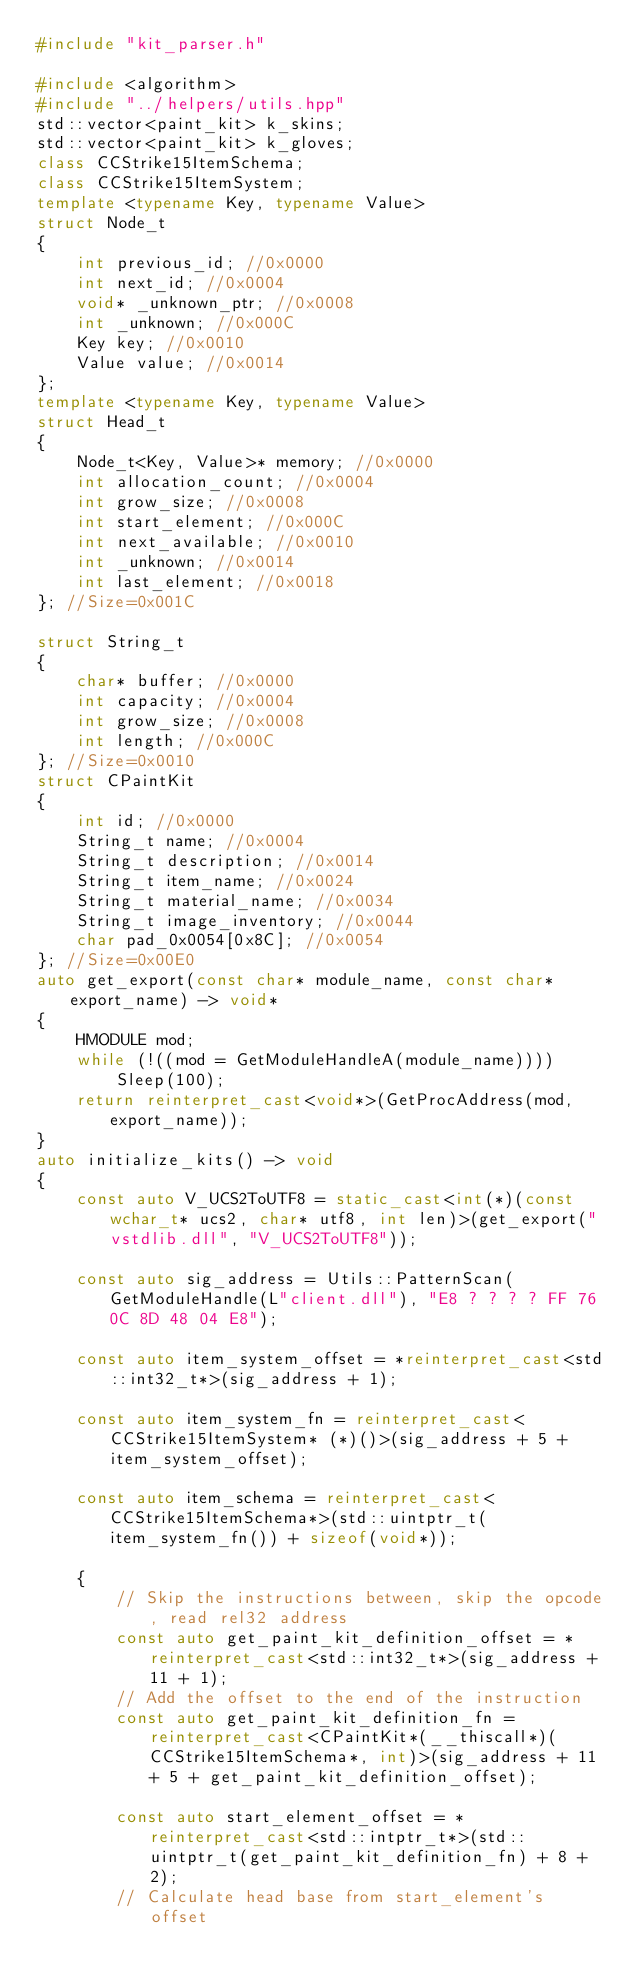Convert code to text. <code><loc_0><loc_0><loc_500><loc_500><_C++_>#include "kit_parser.h"

#include <algorithm>
#include "../helpers/utils.hpp"
std::vector<paint_kit> k_skins;
std::vector<paint_kit> k_gloves;
class CCStrike15ItemSchema;
class CCStrike15ItemSystem;
template <typename Key, typename Value>
struct Node_t
{
	int previous_id; //0x0000
	int next_id; //0x0004
	void* _unknown_ptr; //0x0008
	int _unknown; //0x000C
	Key key; //0x0010
	Value value; //0x0014
};
template <typename Key, typename Value>
struct Head_t
{
	Node_t<Key, Value>* memory; //0x0000
	int allocation_count; //0x0004
	int grow_size; //0x0008
	int start_element; //0x000C
	int next_available; //0x0010
	int _unknown; //0x0014
	int last_element; //0x0018
}; //Size=0x001C
  
struct String_t
{
	char* buffer; //0x0000
	int capacity; //0x0004
	int grow_size; //0x0008
	int length; //0x000C
}; //Size=0x0010
struct CPaintKit
{
	int id; //0x0000
	String_t name; //0x0004
	String_t description; //0x0014
	String_t item_name; //0x0024
	String_t material_name; //0x0034
	String_t image_inventory; //0x0044
	char pad_0x0054[0x8C]; //0x0054
}; //Size=0x00E0
auto get_export(const char* module_name, const char* export_name) -> void*
{
	HMODULE mod;
	while (!((mod = GetModuleHandleA(module_name))))
		Sleep(100);
	return reinterpret_cast<void*>(GetProcAddress(mod, export_name));
}
auto initialize_kits() -> void
{
	const auto V_UCS2ToUTF8 = static_cast<int(*)(const wchar_t* ucs2, char* utf8, int len)>(get_export("vstdlib.dll", "V_UCS2ToUTF8"));

	const auto sig_address = Utils::PatternScan(GetModuleHandle(L"client.dll"), "E8 ? ? ? ? FF 76 0C 8D 48 04 E8");
	
	const auto item_system_offset = *reinterpret_cast<std::int32_t*>(sig_address + 1);

	const auto item_system_fn = reinterpret_cast<CCStrike15ItemSystem* (*)()>(sig_address + 5 + item_system_offset);

	const auto item_schema = reinterpret_cast<CCStrike15ItemSchema*>(std::uintptr_t(item_system_fn()) + sizeof(void*));
	
	{
		// Skip the instructions between, skip the opcode, read rel32 address
		const auto get_paint_kit_definition_offset = *reinterpret_cast<std::int32_t*>(sig_address + 11 + 1);
		// Add the offset to the end of the instruction
		const auto get_paint_kit_definition_fn = reinterpret_cast<CPaintKit*(__thiscall*)(CCStrike15ItemSchema*, int)>(sig_address + 11 + 5 + get_paint_kit_definition_offset);
	
		const auto start_element_offset = *reinterpret_cast<std::intptr_t*>(std::uintptr_t(get_paint_kit_definition_fn) + 8 + 2);
		// Calculate head base from start_element's offset</code> 